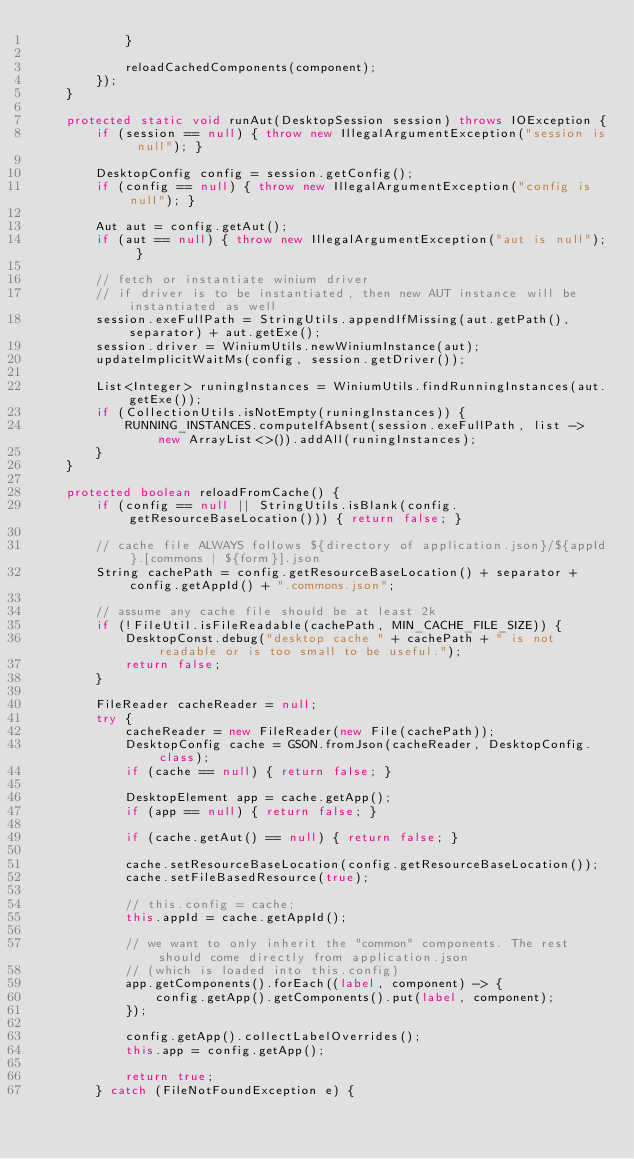<code> <loc_0><loc_0><loc_500><loc_500><_Java_>            }

            reloadCachedComponents(component);
        });
    }

    protected static void runAut(DesktopSession session) throws IOException {
        if (session == null) { throw new IllegalArgumentException("session is null"); }

        DesktopConfig config = session.getConfig();
        if (config == null) { throw new IllegalArgumentException("config is null"); }

        Aut aut = config.getAut();
        if (aut == null) { throw new IllegalArgumentException("aut is null"); }

        // fetch or instantiate winium driver
        // if driver is to be instantiated, then new AUT instance will be instantiated as well
        session.exeFullPath = StringUtils.appendIfMissing(aut.getPath(), separator) + aut.getExe();
        session.driver = WiniumUtils.newWiniumInstance(aut);
        updateImplicitWaitMs(config, session.getDriver());

        List<Integer> runingInstances = WiniumUtils.findRunningInstances(aut.getExe());
        if (CollectionUtils.isNotEmpty(runingInstances)) {
            RUNNING_INSTANCES.computeIfAbsent(session.exeFullPath, list -> new ArrayList<>()).addAll(runingInstances);
        }
    }

    protected boolean reloadFromCache() {
        if (config == null || StringUtils.isBlank(config.getResourceBaseLocation())) { return false; }

        // cache file ALWAYS follows ${directory of application.json}/${appId}.[commons | ${form}].json
        String cachePath = config.getResourceBaseLocation() + separator + config.getAppId() + ".commons.json";

        // assume any cache file should be at least 2k
        if (!FileUtil.isFileReadable(cachePath, MIN_CACHE_FILE_SIZE)) {
            DesktopConst.debug("desktop cache " + cachePath + " is not readable or is too small to be useful.");
            return false;
        }

        FileReader cacheReader = null;
        try {
            cacheReader = new FileReader(new File(cachePath));
            DesktopConfig cache = GSON.fromJson(cacheReader, DesktopConfig.class);
            if (cache == null) { return false; }

            DesktopElement app = cache.getApp();
            if (app == null) { return false; }

            if (cache.getAut() == null) { return false; }

            cache.setResourceBaseLocation(config.getResourceBaseLocation());
            cache.setFileBasedResource(true);

            // this.config = cache;
            this.appId = cache.getAppId();

            // we want to only inherit the "common" components. The rest should come directly from application.json
            // (which is loaded into this.config)
            app.getComponents().forEach((label, component) -> {
                config.getApp().getComponents().put(label, component);
            });

            config.getApp().collectLabelOverrides();
            this.app = config.getApp();

            return true;
        } catch (FileNotFoundException e) {</code> 